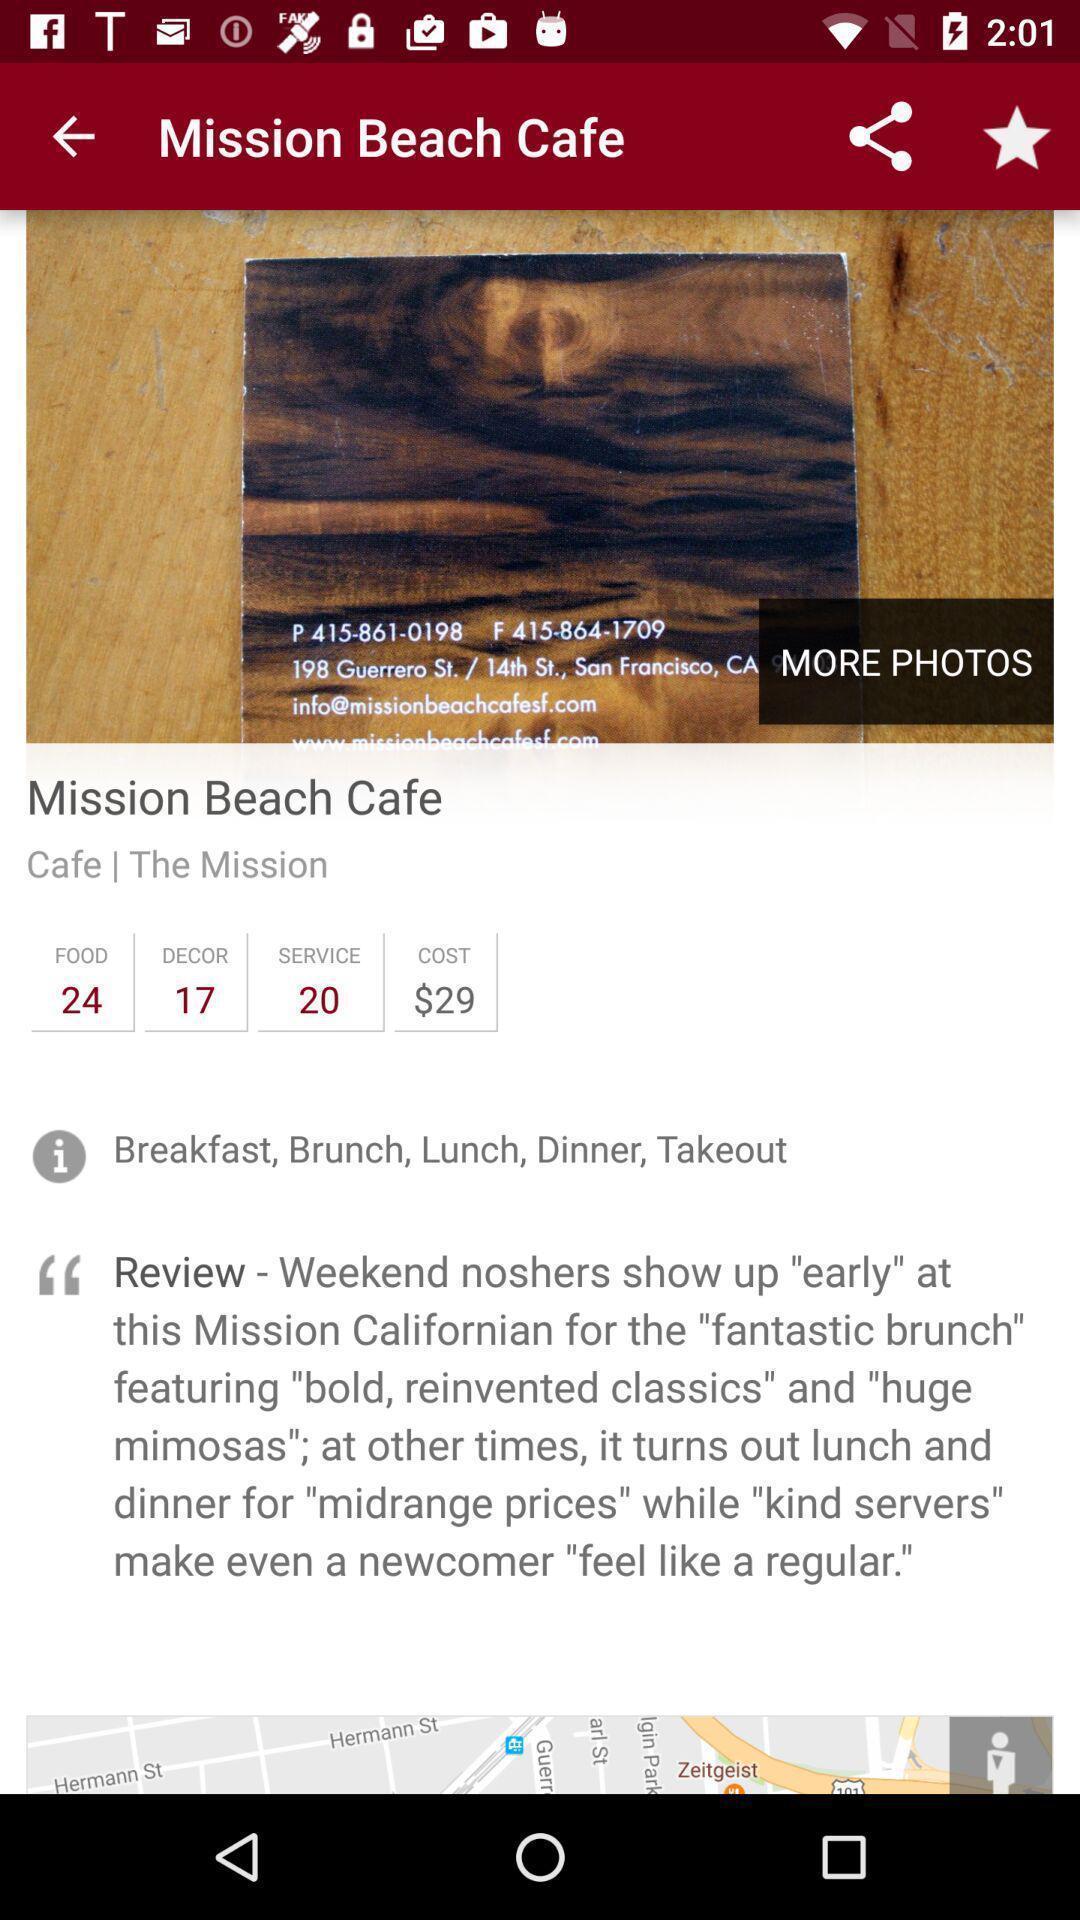What can you discern from this picture? Screen page displyaing the information of restaurant. 